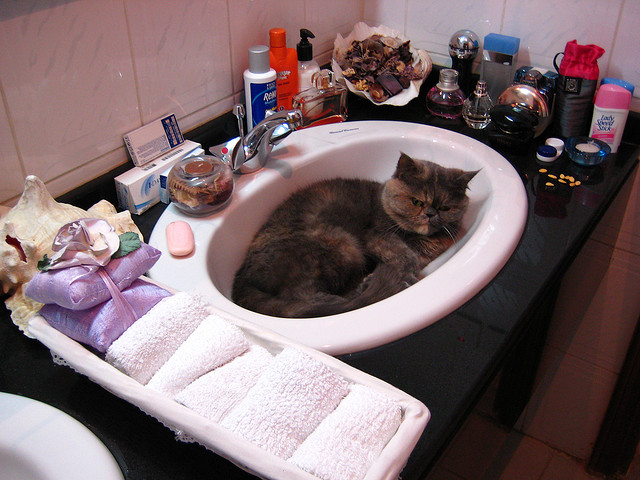What items do you notice on the right side of the sink? To the right, there are several grooming items including a safety razor, a bottle of aftershave, and a couple of perfume bottles, indicating the space is used for personal care routines. What else can be inferred about the cat's environment? The cat is in a well-stocked bathroom, likely in a home environment, suggesting the residents value personal grooming and comfort, as evidenced by the variety of toiletries and the clean towels. 